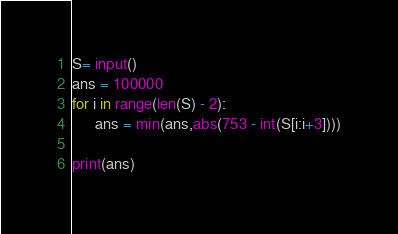Convert code to text. <code><loc_0><loc_0><loc_500><loc_500><_Python_>S= input()
ans = 100000
for i in range(len(S) - 2):
      ans = min(ans,abs(753 - int(S[i:i+3])))
                            
print(ans)
</code> 